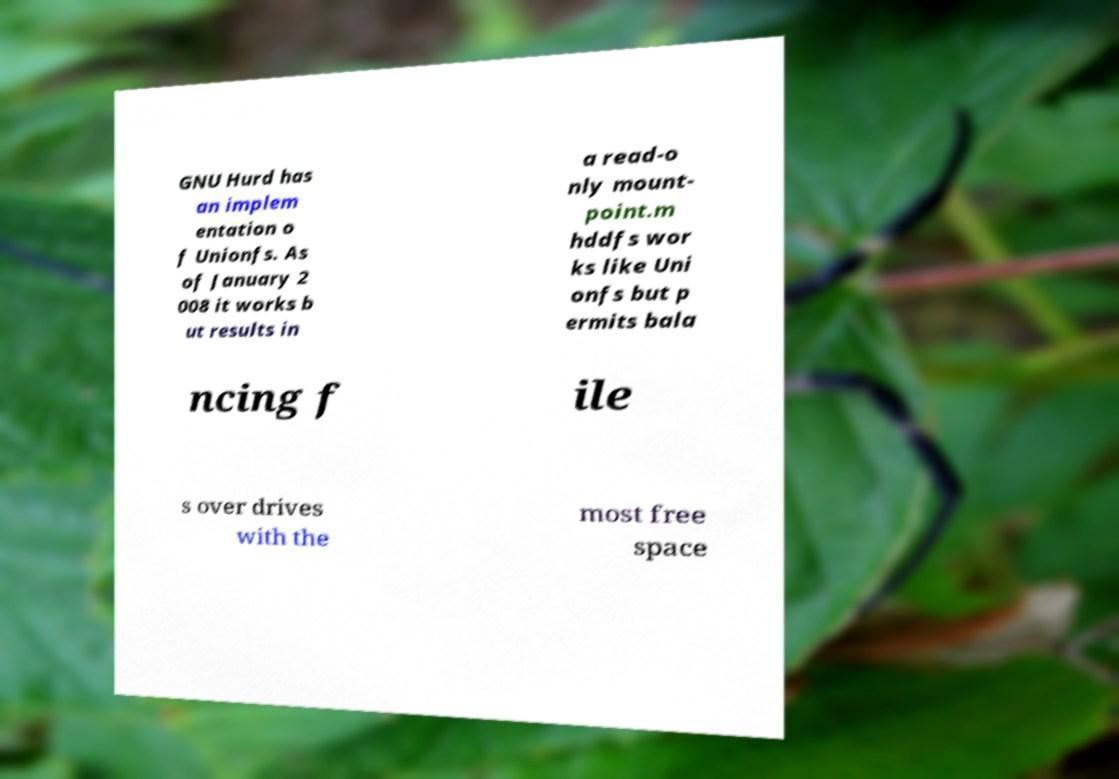What messages or text are displayed in this image? I need them in a readable, typed format. GNU Hurd has an implem entation o f Unionfs. As of January 2 008 it works b ut results in a read-o nly mount- point.m hddfs wor ks like Uni onfs but p ermits bala ncing f ile s over drives with the most free space 